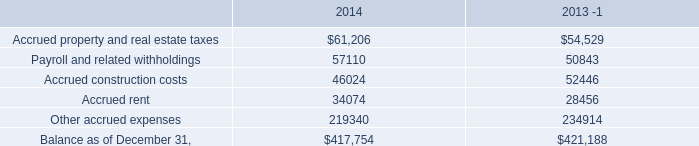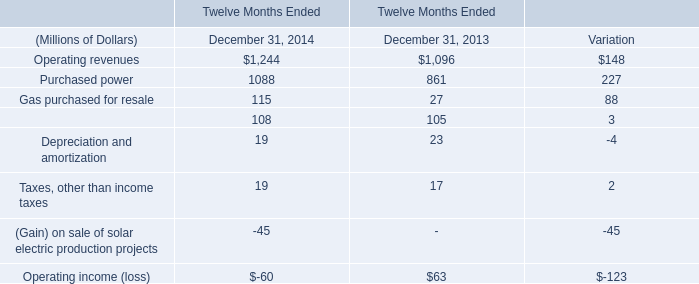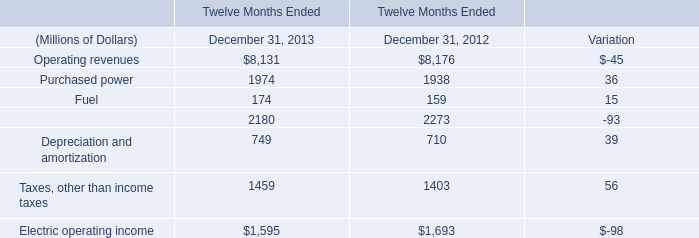What's the current growth rate of purchased power? (in %) 
Computations: (36 / 1938)
Answer: 0.01858. 